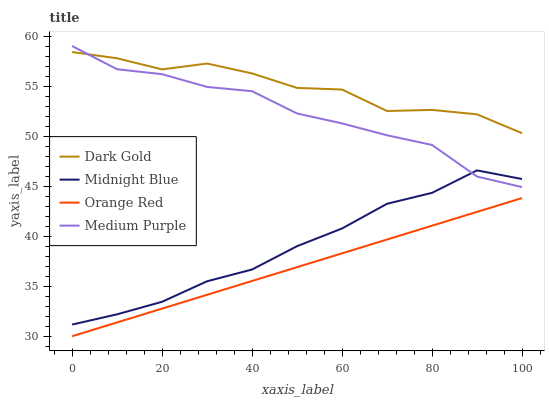Does Midnight Blue have the minimum area under the curve?
Answer yes or no. No. Does Midnight Blue have the maximum area under the curve?
Answer yes or no. No. Is Midnight Blue the smoothest?
Answer yes or no. No. Is Midnight Blue the roughest?
Answer yes or no. No. Does Midnight Blue have the lowest value?
Answer yes or no. No. Does Midnight Blue have the highest value?
Answer yes or no. No. Is Midnight Blue less than Dark Gold?
Answer yes or no. Yes. Is Dark Gold greater than Midnight Blue?
Answer yes or no. Yes. Does Midnight Blue intersect Dark Gold?
Answer yes or no. No. 